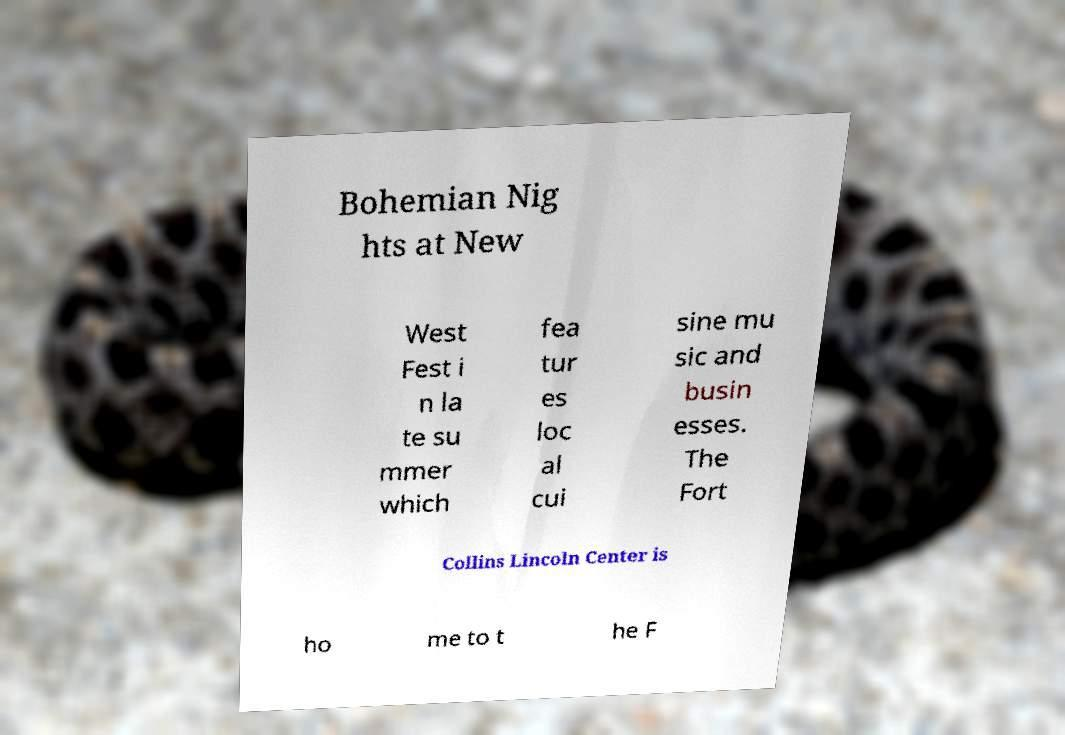Can you accurately transcribe the text from the provided image for me? Bohemian Nig hts at New West Fest i n la te su mmer which fea tur es loc al cui sine mu sic and busin esses. The Fort Collins Lincoln Center is ho me to t he F 